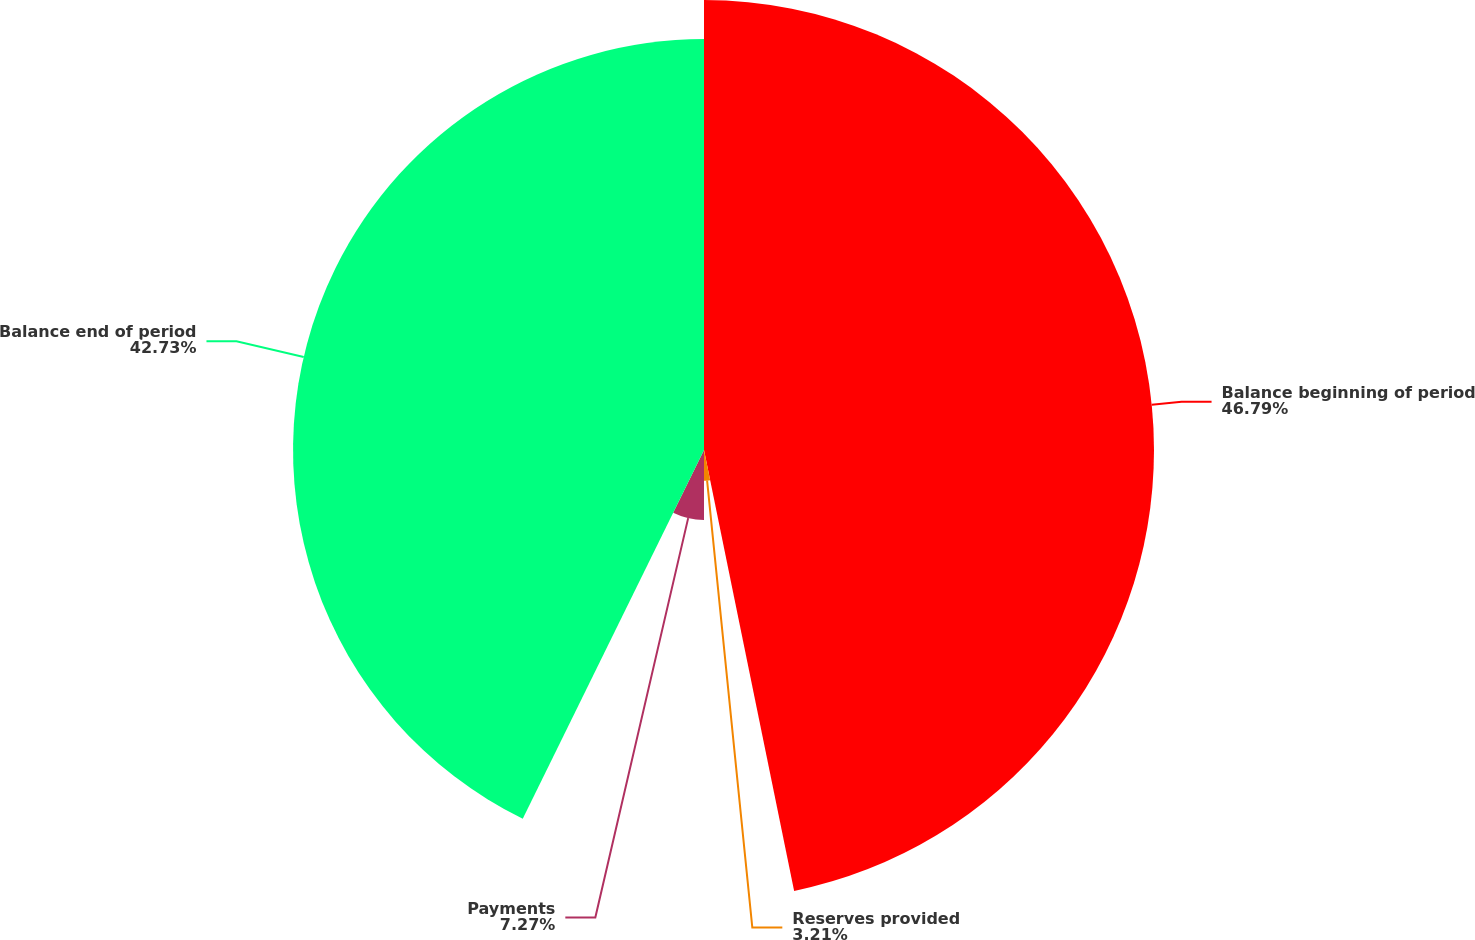<chart> <loc_0><loc_0><loc_500><loc_500><pie_chart><fcel>Balance beginning of period<fcel>Reserves provided<fcel>Payments<fcel>Balance end of period<nl><fcel>46.79%<fcel>3.21%<fcel>7.27%<fcel>42.73%<nl></chart> 